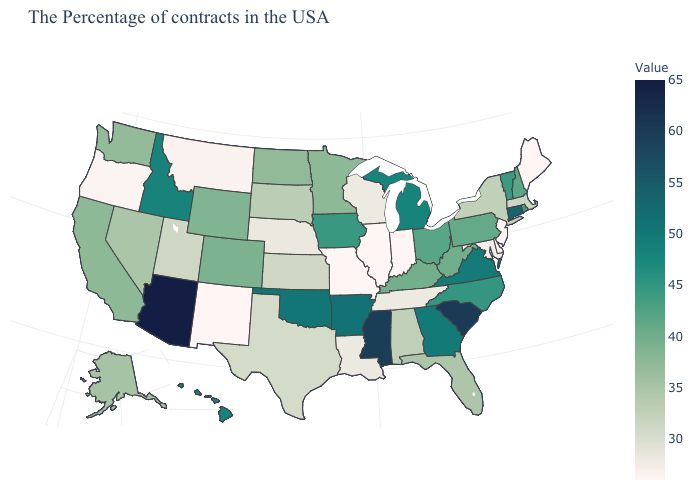Among the states that border Kansas , does Missouri have the lowest value?
Give a very brief answer. Yes. Among the states that border Alabama , which have the highest value?
Give a very brief answer. Mississippi. Among the states that border Mississippi , does Tennessee have the lowest value?
Keep it brief. Yes. Which states have the lowest value in the USA?
Concise answer only. Maine, New Jersey, Delaware, Indiana, Illinois, Missouri, New Mexico. Is the legend a continuous bar?
Be succinct. Yes. Which states have the highest value in the USA?
Answer briefly. Arizona. 